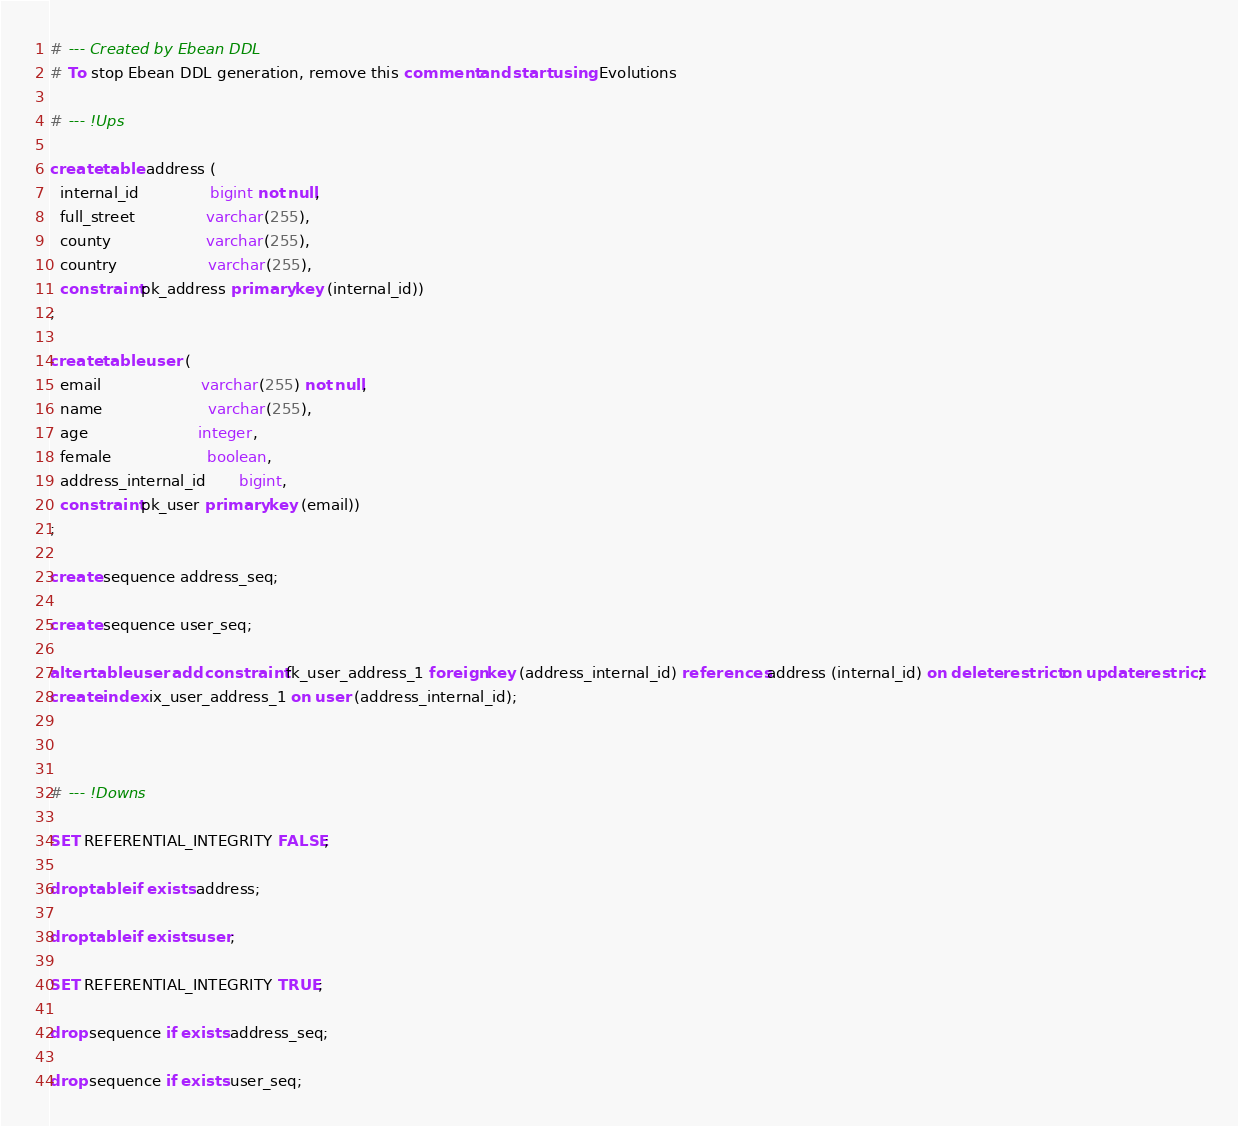<code> <loc_0><loc_0><loc_500><loc_500><_SQL_># --- Created by Ebean DDL
# To stop Ebean DDL generation, remove this comment and start using Evolutions

# --- !Ups

create table address (
  internal_id               bigint not null,
  full_street               varchar(255),
  county                    varchar(255),
  country                   varchar(255),
  constraint pk_address primary key (internal_id))
;

create table user (
  email                     varchar(255) not null,
  name                      varchar(255),
  age                       integer,
  female                    boolean,
  address_internal_id       bigint,
  constraint pk_user primary key (email))
;

create sequence address_seq;

create sequence user_seq;

alter table user add constraint fk_user_address_1 foreign key (address_internal_id) references address (internal_id) on delete restrict on update restrict;
create index ix_user_address_1 on user (address_internal_id);



# --- !Downs

SET REFERENTIAL_INTEGRITY FALSE;

drop table if exists address;

drop table if exists user;

SET REFERENTIAL_INTEGRITY TRUE;

drop sequence if exists address_seq;

drop sequence if exists user_seq;

</code> 